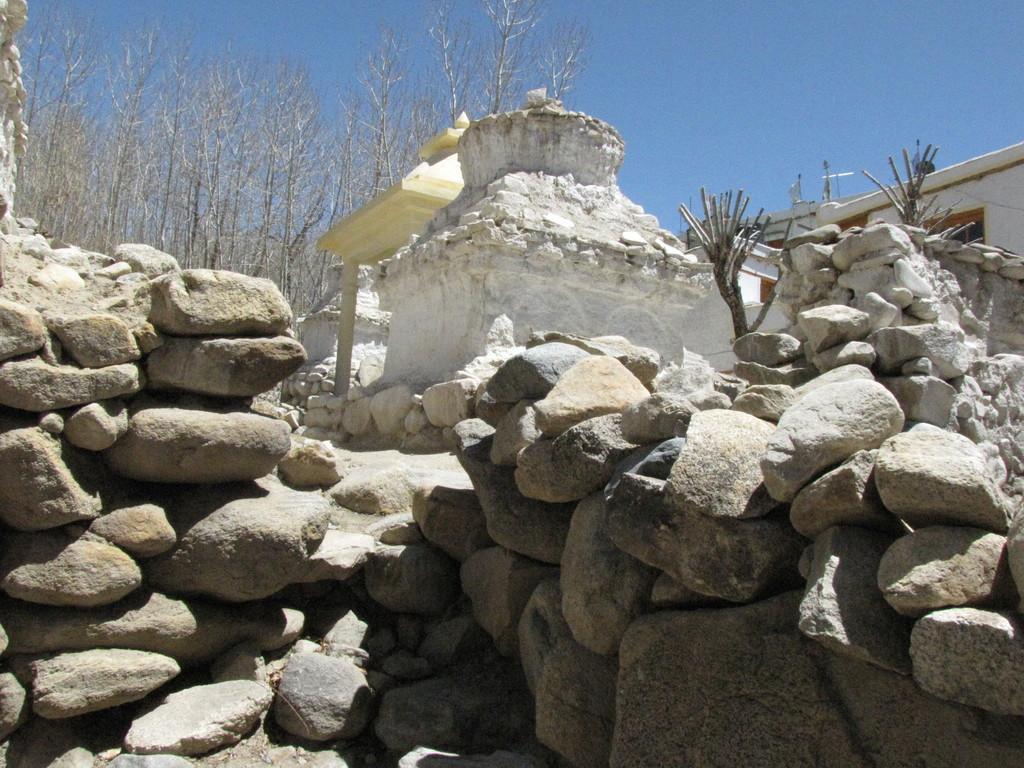Can you describe this image briefly? In the picture we can see some rocks on it, we can see an old house structure with a white paint to it and behind it, we can see some trees which are dried and in the background we can see a sky which is blue in color. 